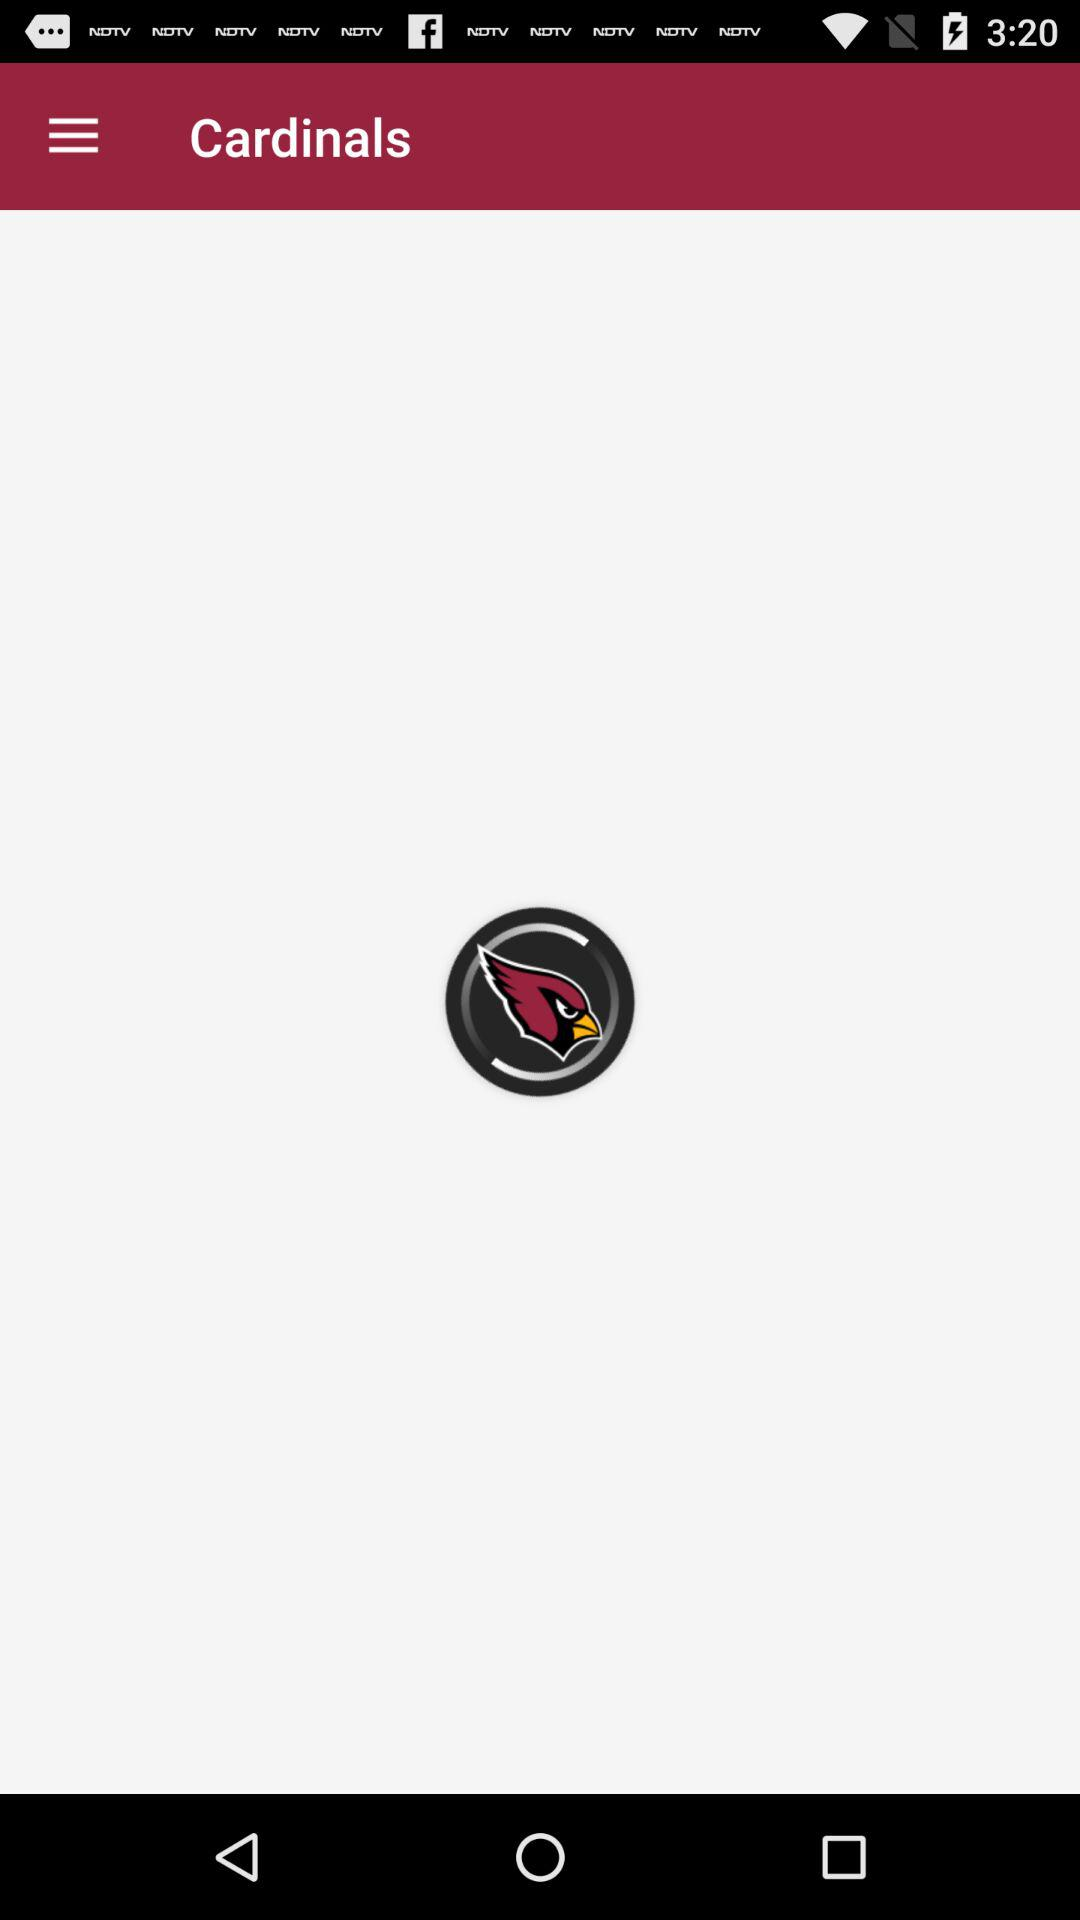What is the application name? The application name is "Cardinals". 